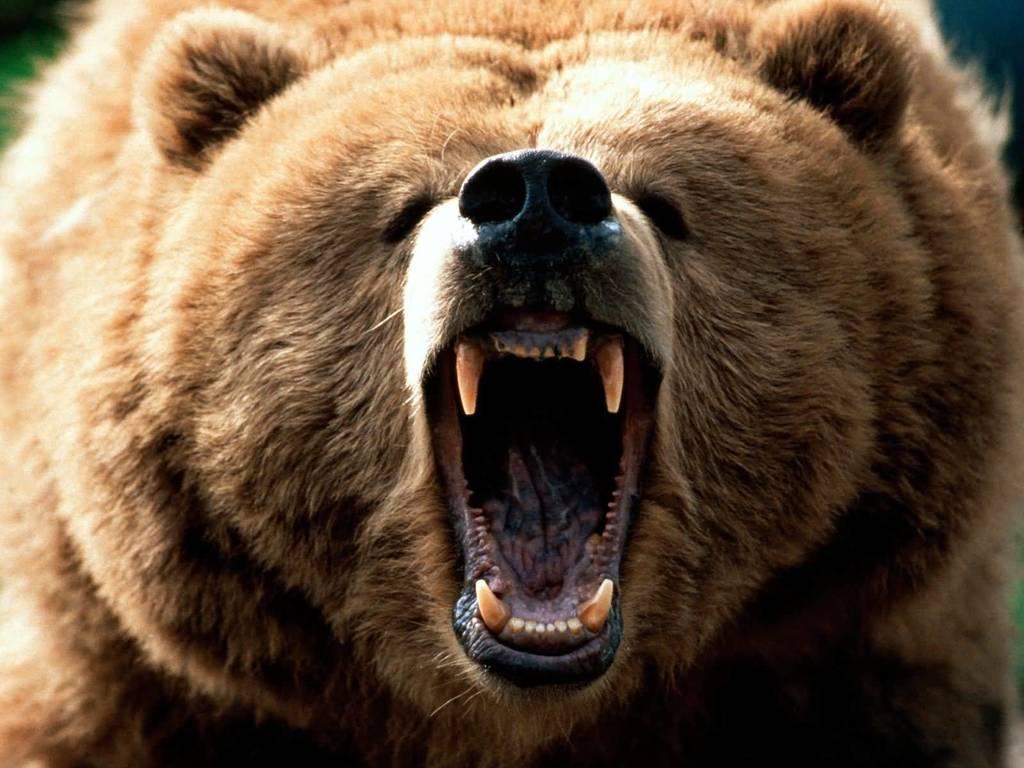Describe this image in one or two sentences. In this picture we can see a brown bear. Here we can see jaws of a bear. 